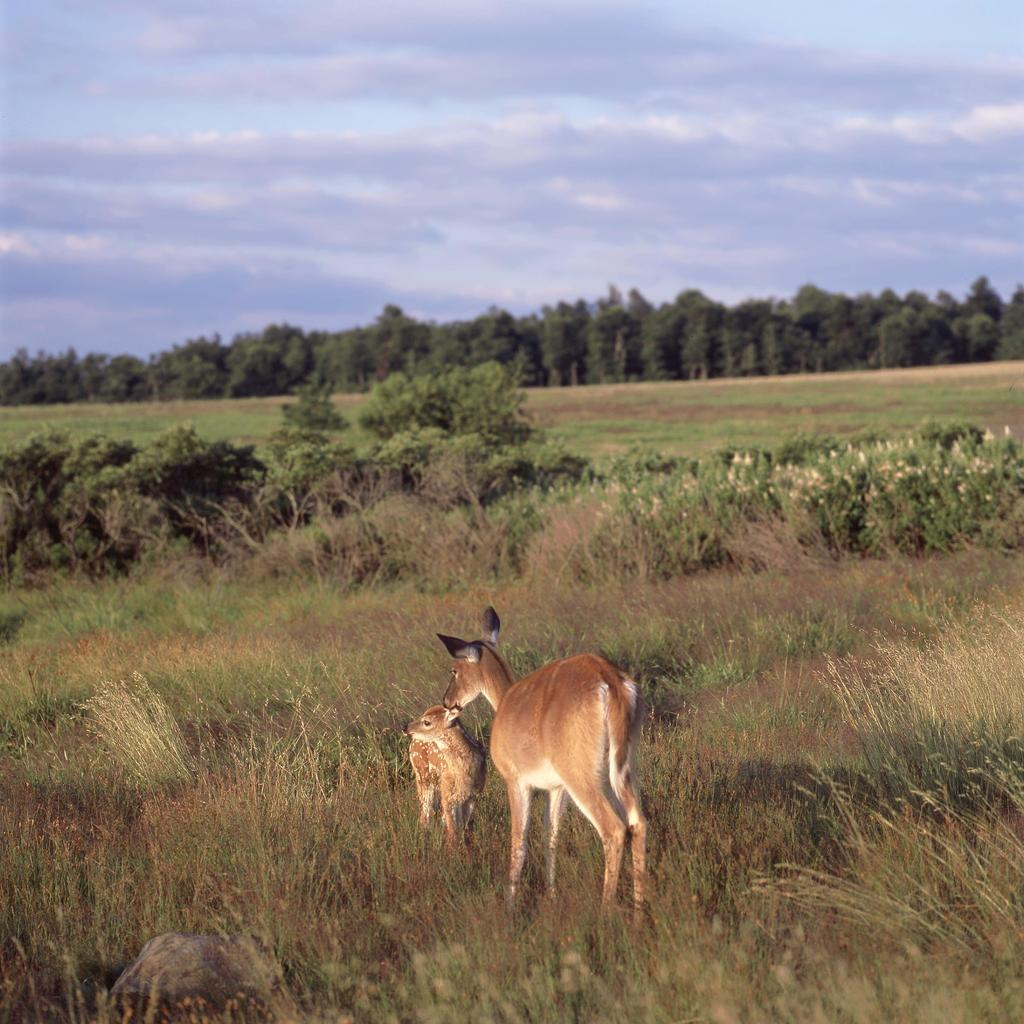How many deer are present in the image? There are 2 deer in the image. Where are the deer located in relation to other elements in the image? The deer are in front of the other elements in the image. What type of vegetation can be seen in the image? There is grass and plants visible in the image. What is visible in the background of the image? There are trees in the background of the image. What can be seen in the sky in the image? The sky is visible in the image, and it is cloudy. How many boys are skating on one leg in the image? There are no boys or skating activities present in the image. 